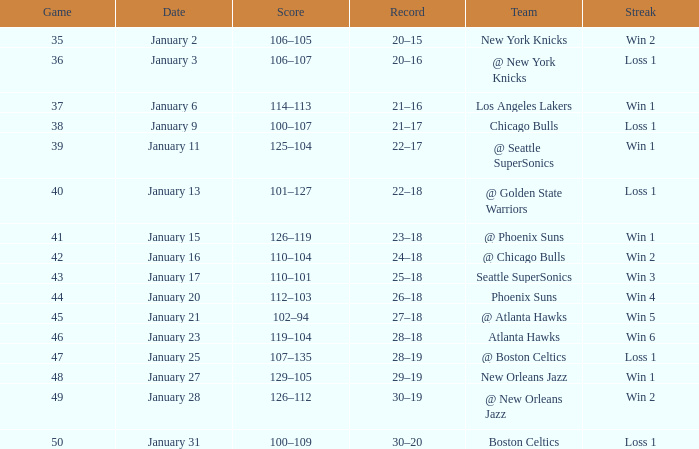What is the Team in Game 41? @ Phoenix Suns. 